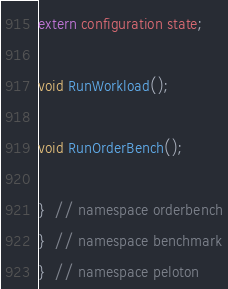<code> <loc_0><loc_0><loc_500><loc_500><_C_>
extern configuration state;

void RunWorkload();

void RunOrderBench();

}  // namespace orderbench
}  // namespace benchmark
}  // namespace peloton</code> 